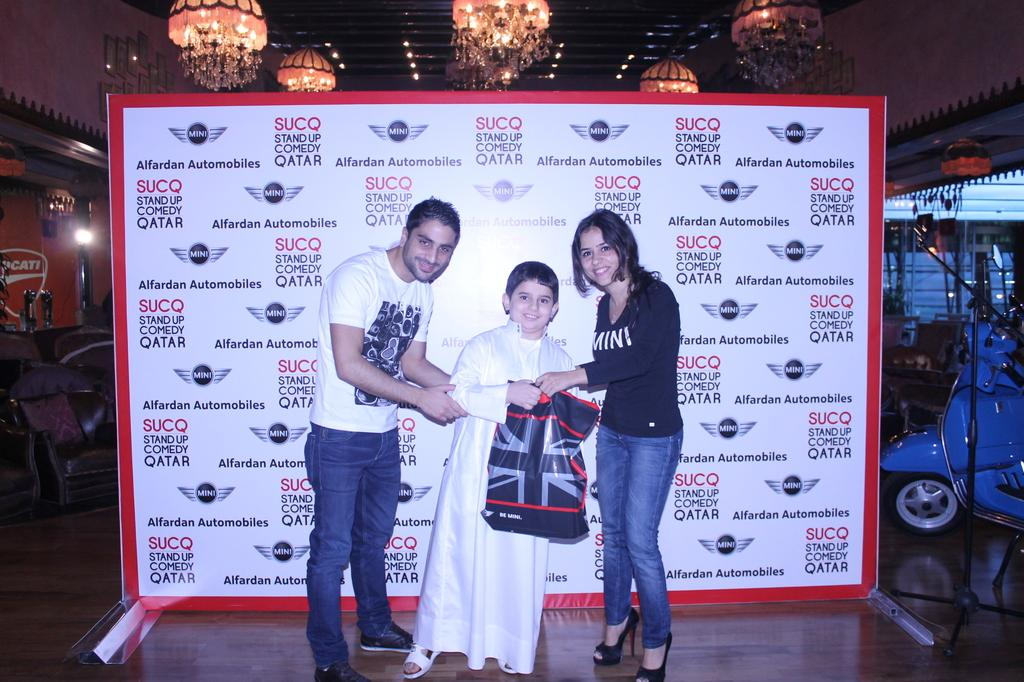<image>
Render a clear and concise summary of the photo. Two adults and a child stand in front of a board with an automobile logo on it. 